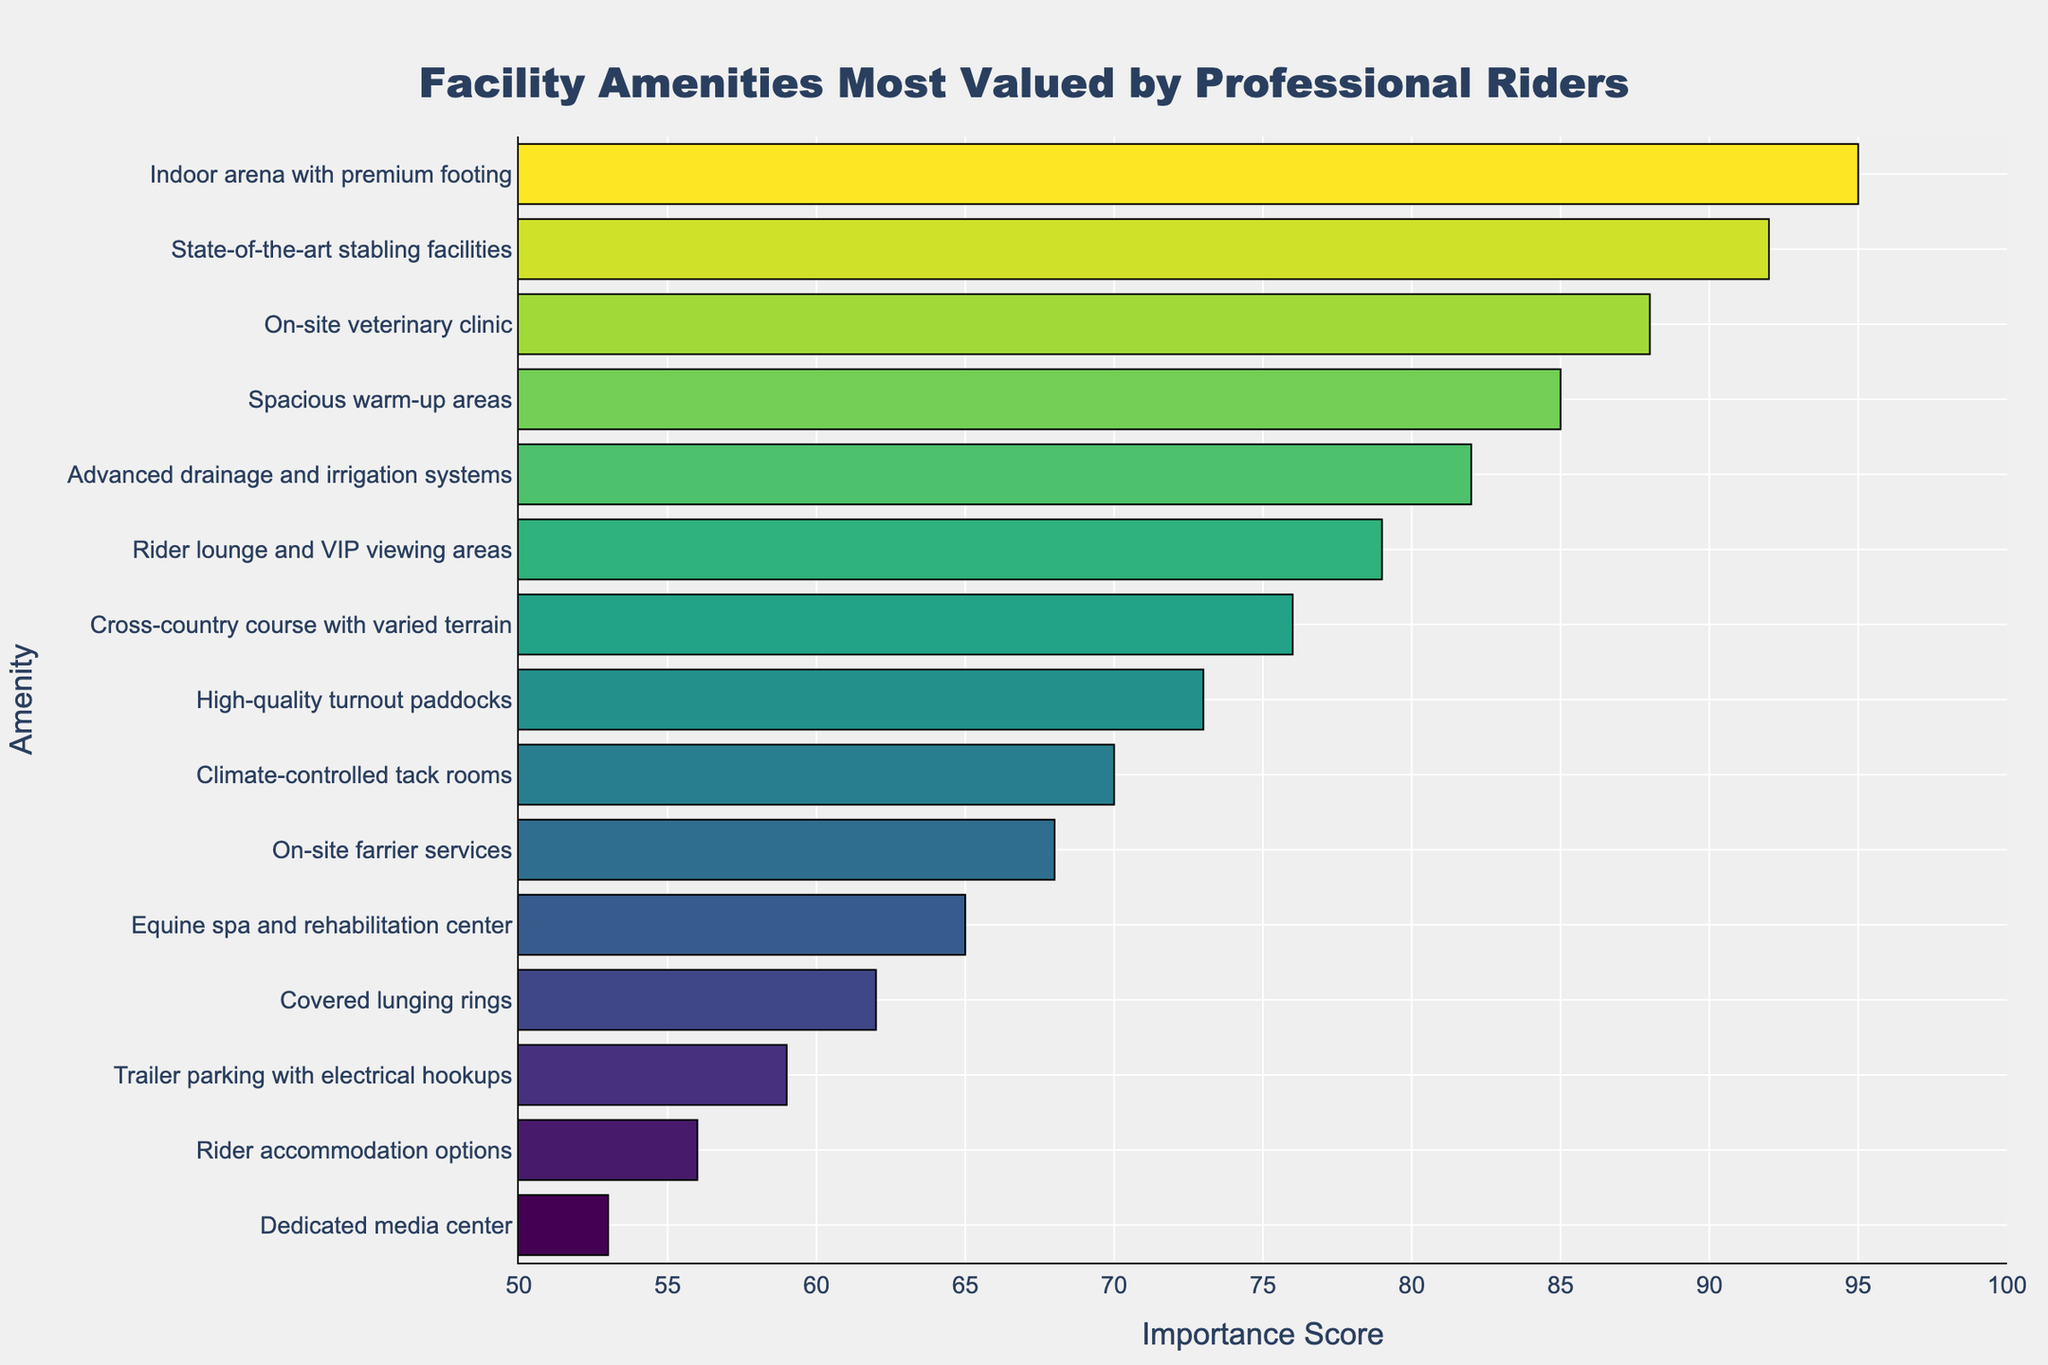Which facility amenity received the highest importance score? The bar chart shows the importance scores for various amenities, with the highest importance score at the top. The "Indoor arena with premium footing" has the highest score.
Answer: Indoor arena with premium footing What is the difference in importance scores between the "Equine spa and rehabilitation center" and the "On-site farrier services"? The importance score for the "Equine spa and rehabilitation center" is 65, and for the "On-site farrier services" it is 68. The difference is calculated as 68 - 65.
Answer: 3 Which amenity has a greater importance score, "Cross-country course with varied terrain" or "Rider lounge and VIP viewing areas"? The bar chart shows the importance scores for these amenities. "Rider lounge and VIP viewing areas" has a score of 79, while "Cross-country course with varied terrain" has a score of 76. 79 is greater than 76.
Answer: Rider lounge and VIP viewing areas What is the average importance score of the top three most valued amenities? The top three amenities are "Indoor arena with premium footing" (95), "State-of-the-art stabling facilities" (92), and "On-site veterinary clinic" (88). The average is calculated as (95 + 92 + 88) / 3.
Answer: 91.67 How many amenities have an importance score below 70? The chart needs to be reviewed until all amenities with scores below 70 are identified: "Climate-controlled tack rooms" (70), "On-site farrier services" (68), "Equine spa and rehabilitation center" (65), "Covered lunging rings" (62), "Trailer parking with electrical hookups" (59), "Rider accommodation options" (56), "Dedicated media center" (53). There are 7 amenities.
Answer: 7 Which color gradient was used in the bar chart to represent the importance scores? Upon closer inspection of the color pattern in the bar chart, the colors used are from the "Viridis" color scale, which gradients from green to yellow.
Answer: Viridis 